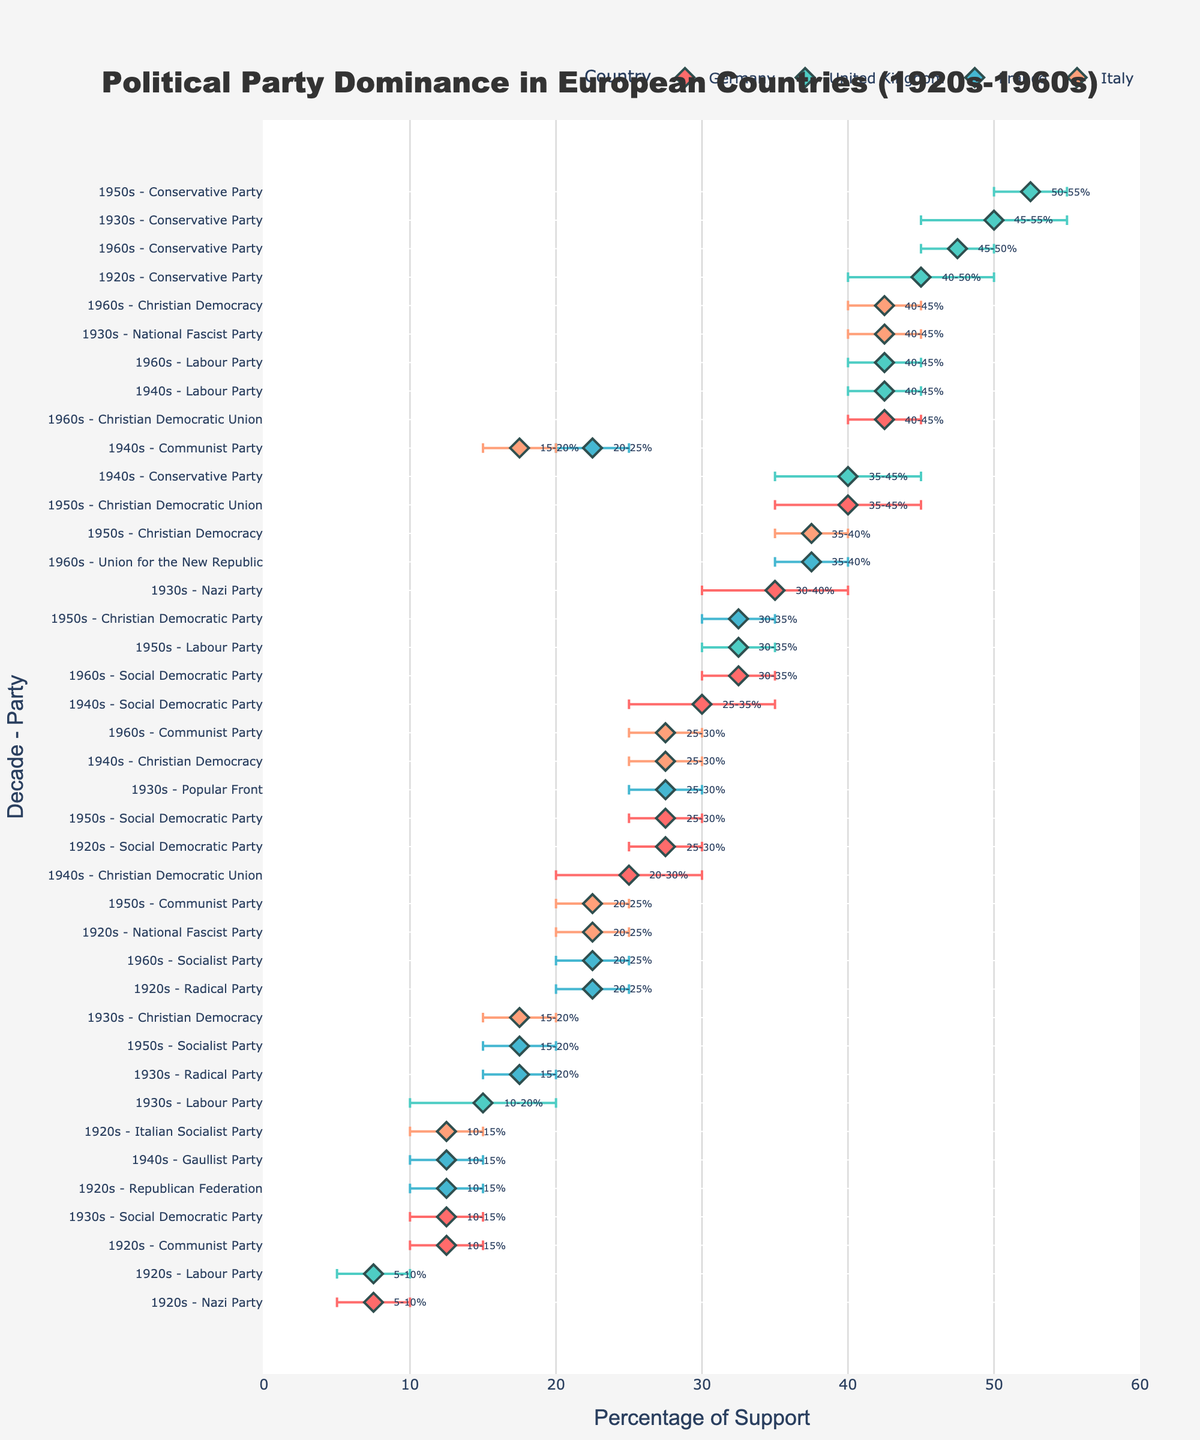What is the main title of the plot? The main title is typically located at the top center of the figure. In this plot, it is specified in the layout settings.
Answer: Political Party Dominance in European Countries (1920s-1960s) What is the maximum percentage of the Conservative Party in the United Kingdom in the 1940s? To find this, look for the entries corresponding to the United Kingdom in the 1940s. The entry for the Conservative Party shows a range of 35-45%, so the maximum percentage is 45%.
Answer: 45% Which party in Germany had the highest average percentage in any decade? To find the highest average percentage, look at the 'Avg_Percentage' values for each party in Germany. The Christian Democratic Union in the 1960s had an average percentage of 42.5.
Answer: Christian Democratic Union How does the support range of the Labour Party in the 1960s compare with that in the 1940s in the United Kingdom? Calculate the ranges for both decades. In the 1940s, the Labour Party's range was 5% (45-40), and in the 1960s, it was also 5% (45-40).
Answer: Both ranges are 5% Which country had the most diverse range of political party dominance in the 1960s? By visually comparing the horizontal spread (range) of the markers in the 1960s for each country, Italy had the widest range from 25% to 45%.
Answer: Italy What percentage range did the National Fascist Party in Italy have in the 1930s? Find the corresponding data point for the National Fascist Party in Italy in the 1930s. The range is from 40% to 45%.
Answer: 40-45% Which decade-party combination in France had the smallest dominance range? Compare the range values for each 'Decade_Party' combination in France. The 'Gaullist Party' in the 1940s had a range of 5% (15-10).
Answer: Gaullist Party in the 1940s How did the dominance of the Communist Party in Germany change from the 1920s to the 1930s? By comparing the ranges: In the 1920s, the range was 10-15%, and in the 1930s, the Communist Party is not listed, indicating a decrease to less than 5%.
Answer: Decreased significantly Which country's parties showed the most consistent dominance throughout the decades? Consistency can be assessed through the size and stability of the 'Range' across all decades. Germany as most parties showed overlapping and similar ranges across decades.
Answer: Germany 